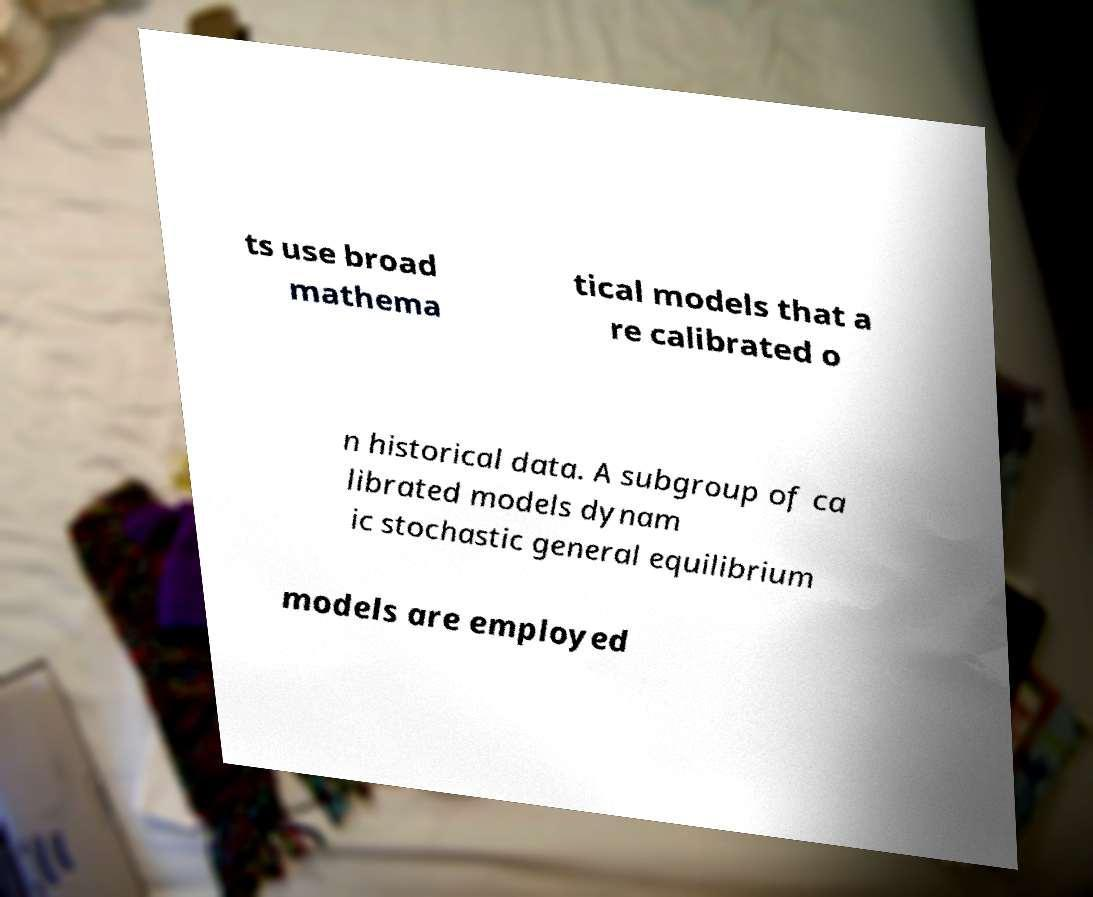Can you accurately transcribe the text from the provided image for me? ts use broad mathema tical models that a re calibrated o n historical data. A subgroup of ca librated models dynam ic stochastic general equilibrium models are employed 